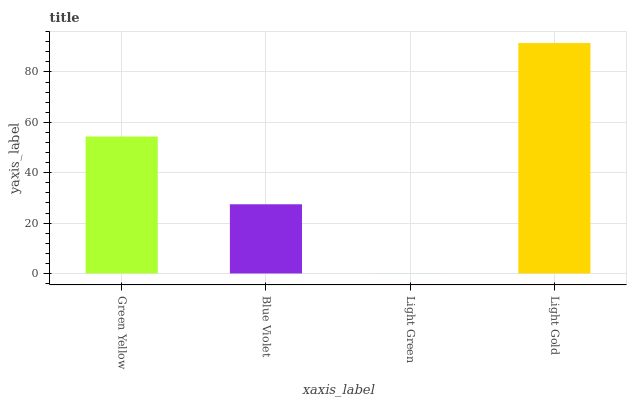Is Light Green the minimum?
Answer yes or no. Yes. Is Light Gold the maximum?
Answer yes or no. Yes. Is Blue Violet the minimum?
Answer yes or no. No. Is Blue Violet the maximum?
Answer yes or no. No. Is Green Yellow greater than Blue Violet?
Answer yes or no. Yes. Is Blue Violet less than Green Yellow?
Answer yes or no. Yes. Is Blue Violet greater than Green Yellow?
Answer yes or no. No. Is Green Yellow less than Blue Violet?
Answer yes or no. No. Is Green Yellow the high median?
Answer yes or no. Yes. Is Blue Violet the low median?
Answer yes or no. Yes. Is Blue Violet the high median?
Answer yes or no. No. Is Light Green the low median?
Answer yes or no. No. 